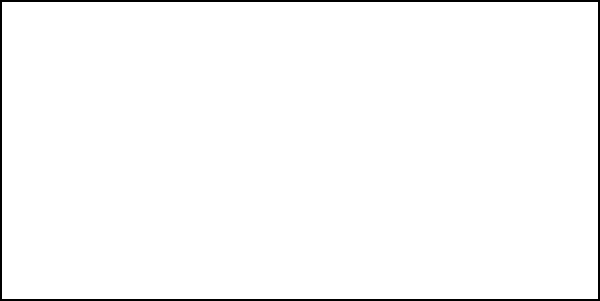A standard American football field is 100 yards long and 50 yards wide. If a circle is inscribed within the football field, touching all four sides, what is the radius of this circle in yards? Let's approach this step-by-step:

1) First, we need to understand that the inscribed circle will touch the middle of each side of the rectangle (football field).

2) The diameter of the circle will be equal to the width of the field, which is 50 yards.

3) Therefore, we can set up the equation:
   
   $$ 2r = 50 $$

   Where $r$ is the radius of the circle.

4) Solving for $r$:
   
   $$ r = \frac{50}{2} = 25 $$

5) We can verify this by considering the length of the field:
   The length is 100 yards, and the diameter takes up 50 yards, leaving 25 yards on each end, which matches our calculated radius.

Thus, the radius of the inscribed circle is 25 yards.
Answer: 25 yards 